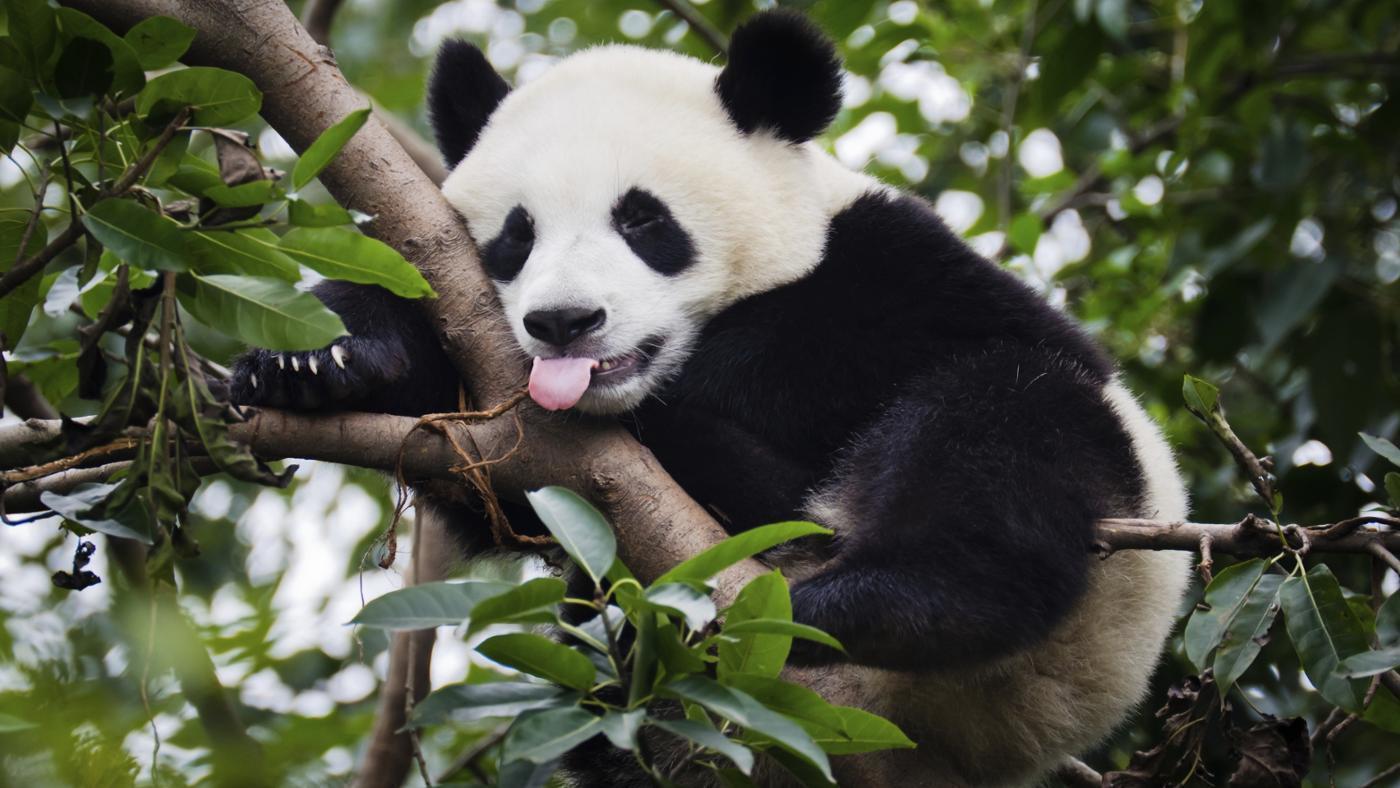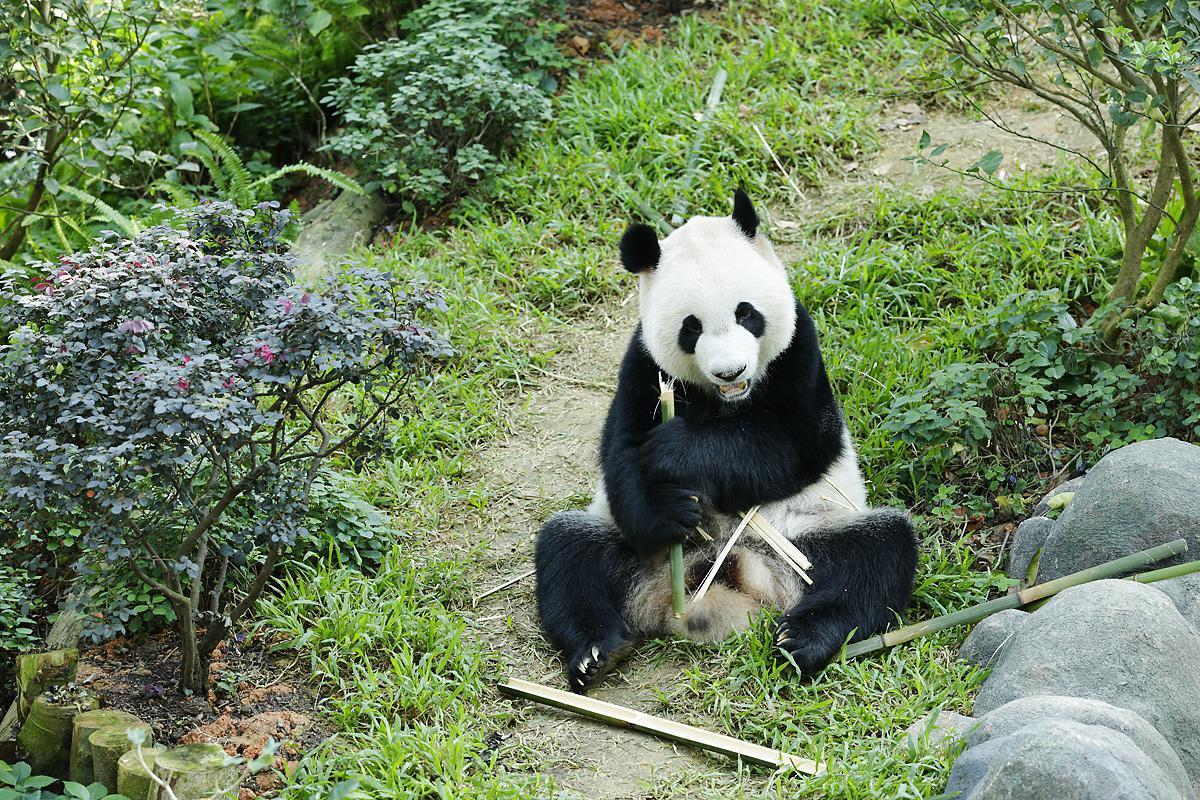The first image is the image on the left, the second image is the image on the right. Evaluate the accuracy of this statement regarding the images: "there is at least one panda in a tree in the image pair". Is it true? Answer yes or no. Yes. The first image is the image on the left, the second image is the image on the right. Examine the images to the left and right. Is the description "At least one panda is in a tree." accurate? Answer yes or no. Yes. 